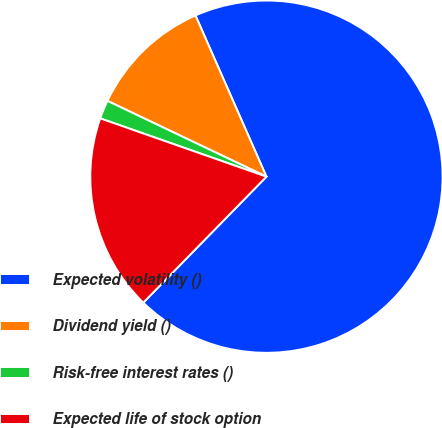Convert chart to OTSL. <chart><loc_0><loc_0><loc_500><loc_500><pie_chart><fcel>Expected volatility ()<fcel>Dividend yield ()<fcel>Risk-free interest rates ()<fcel>Expected life of stock option<nl><fcel>68.92%<fcel>11.32%<fcel>1.71%<fcel>18.05%<nl></chart> 